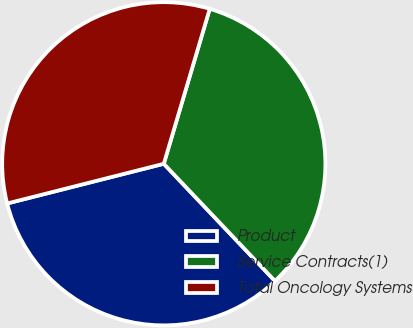Convert chart to OTSL. <chart><loc_0><loc_0><loc_500><loc_500><pie_chart><fcel>Product<fcel>Service Contracts(1)<fcel>Total Oncology Systems<nl><fcel>33.13%<fcel>33.33%<fcel>33.54%<nl></chart> 